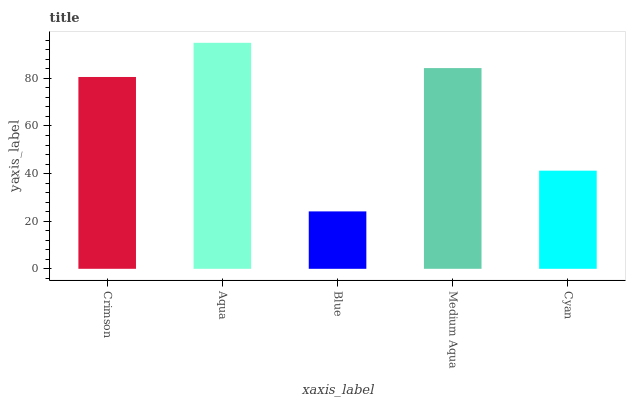Is Blue the minimum?
Answer yes or no. Yes. Is Aqua the maximum?
Answer yes or no. Yes. Is Aqua the minimum?
Answer yes or no. No. Is Blue the maximum?
Answer yes or no. No. Is Aqua greater than Blue?
Answer yes or no. Yes. Is Blue less than Aqua?
Answer yes or no. Yes. Is Blue greater than Aqua?
Answer yes or no. No. Is Aqua less than Blue?
Answer yes or no. No. Is Crimson the high median?
Answer yes or no. Yes. Is Crimson the low median?
Answer yes or no. Yes. Is Blue the high median?
Answer yes or no. No. Is Medium Aqua the low median?
Answer yes or no. No. 